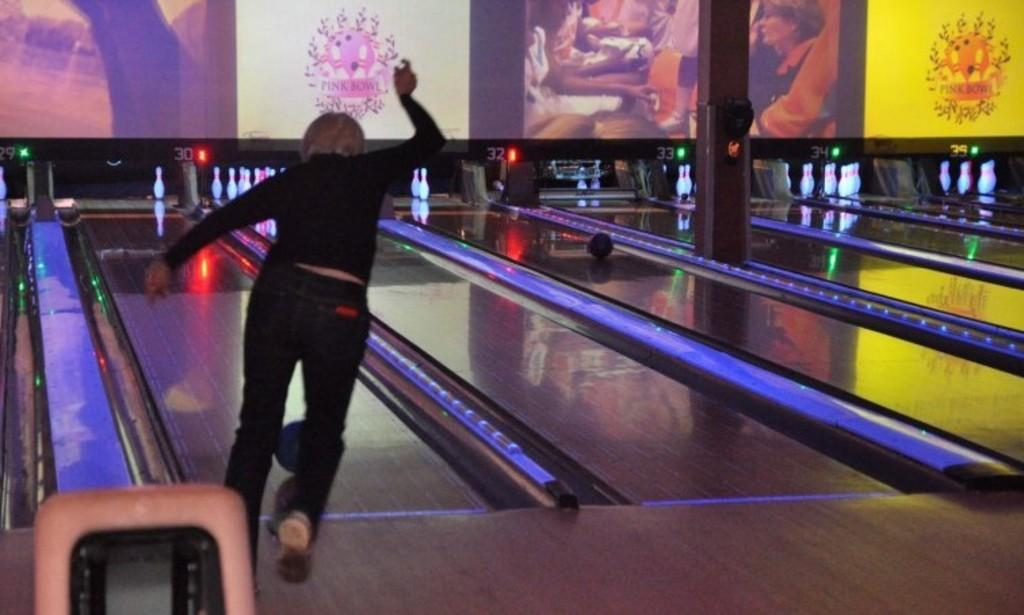Who is the main subject in the image? There is a lady in the image. What is the lady doing in the image? The lady is playing a bowling game and a lounge game. What object can be seen in the image that is related to the games? There is a ball in the image. What can be seen in the background of the image? There are pictures on the wall in the background. What type of bushes can be seen growing near the lady in the image? There are no bushes visible in the image; it is focused on the lady playing games and the surrounding environment does not include any bushes. 